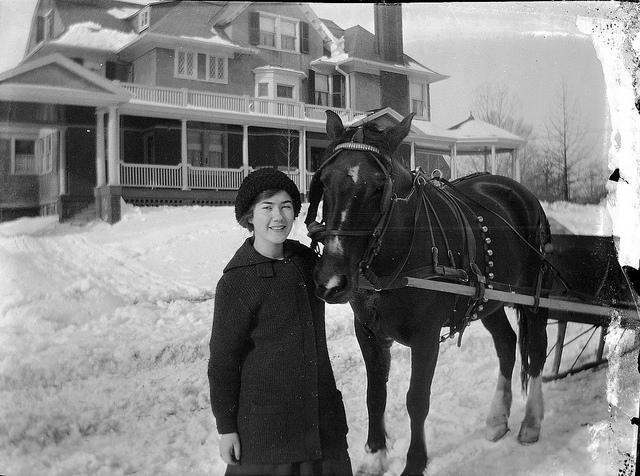How many people are posed?
Give a very brief answer. 1. 